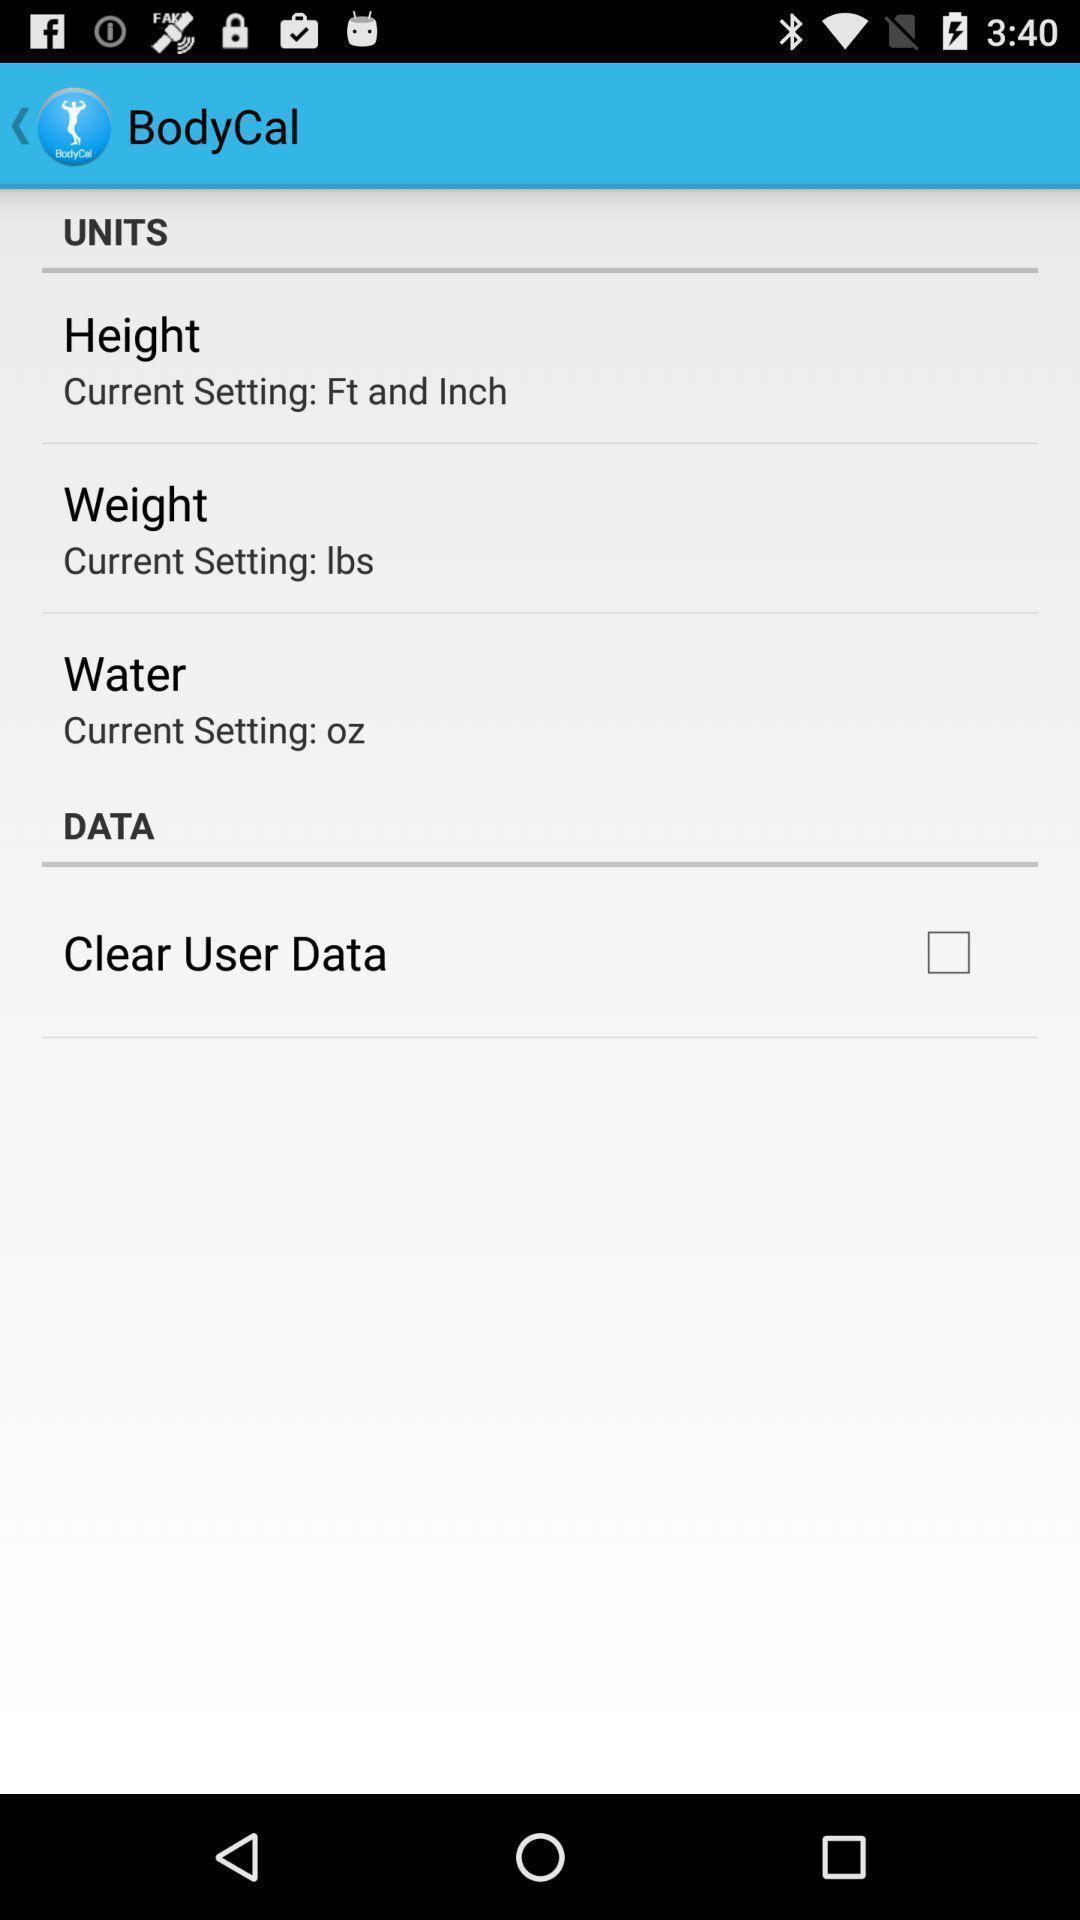Describe the key features of this screenshot. Screen shows units details in a fitness app. 